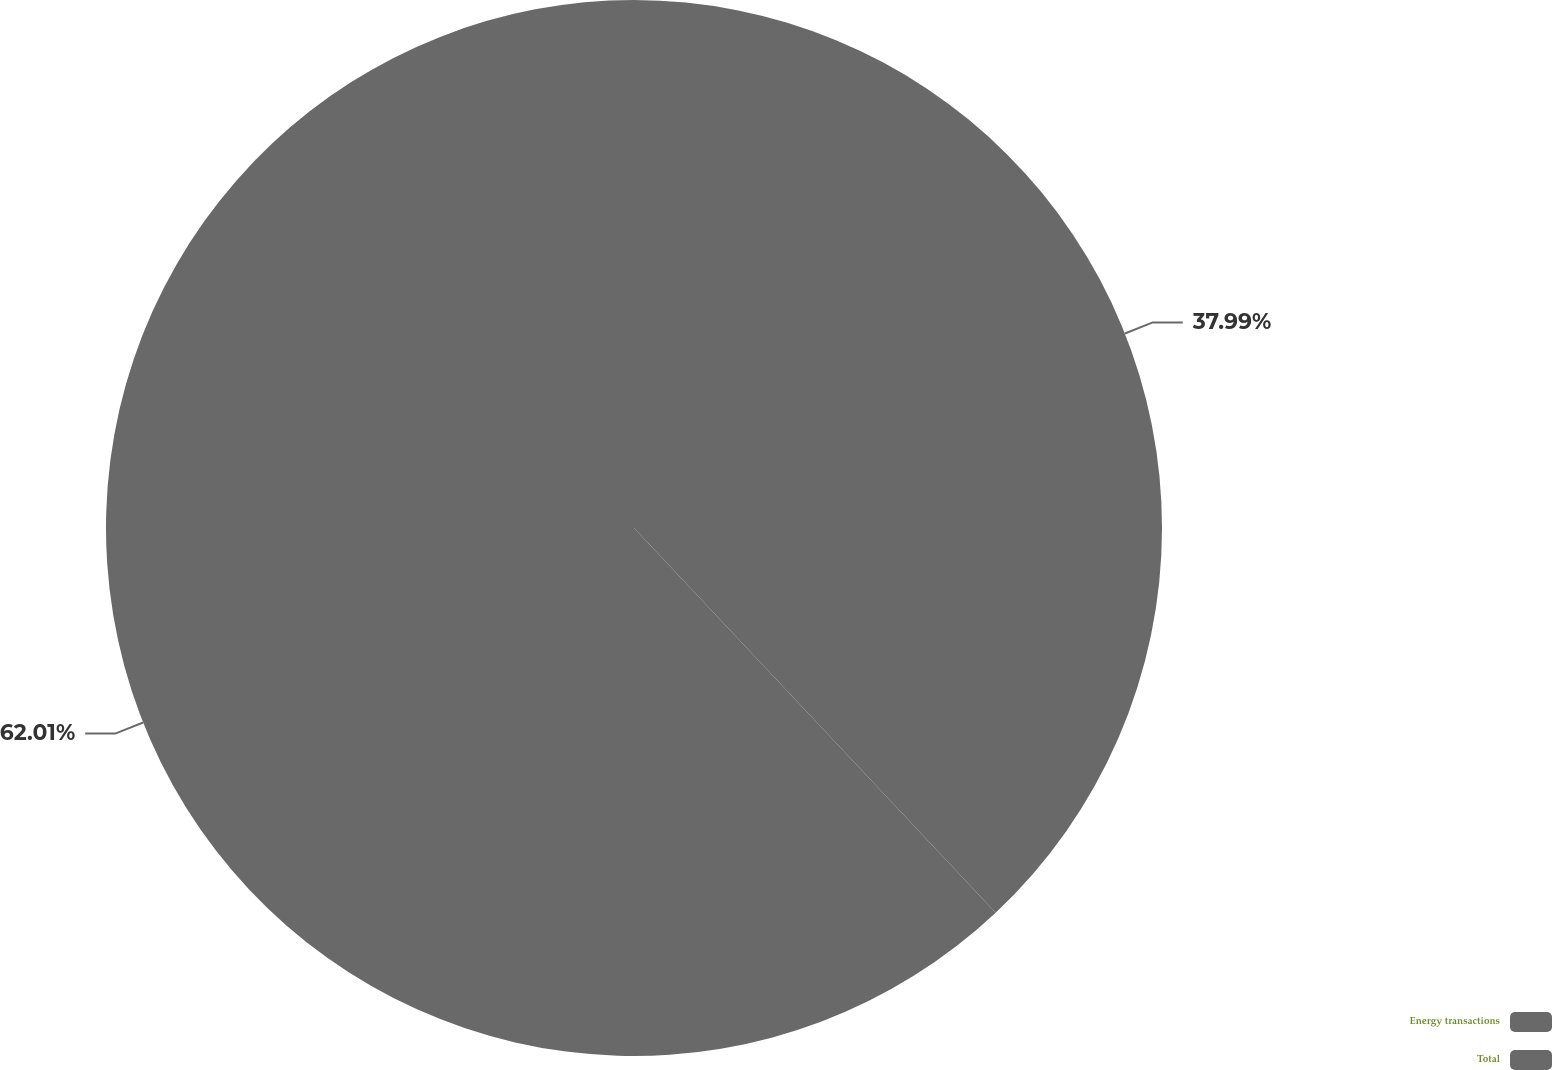Convert chart to OTSL. <chart><loc_0><loc_0><loc_500><loc_500><pie_chart><fcel>Energy transactions<fcel>Total<nl><fcel>37.99%<fcel>62.01%<nl></chart> 